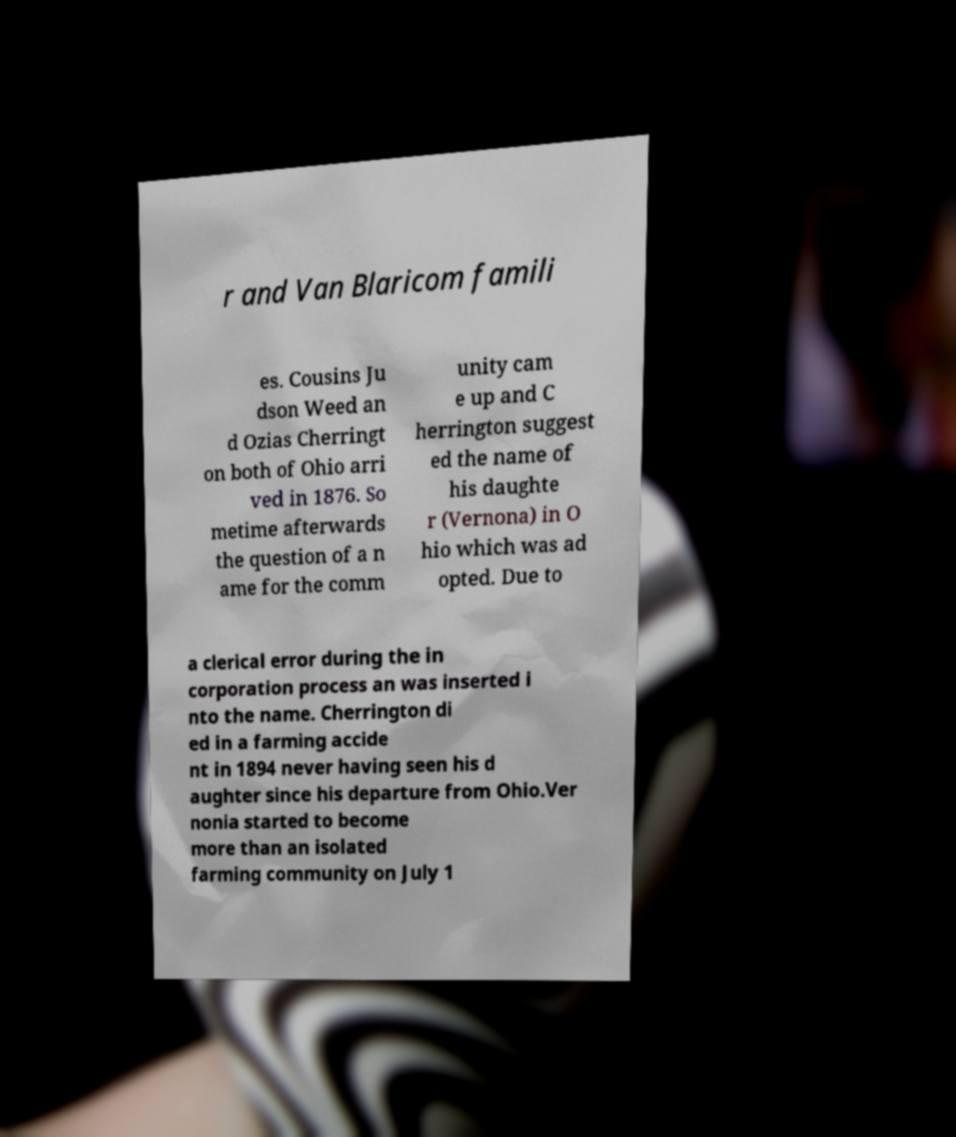I need the written content from this picture converted into text. Can you do that? r and Van Blaricom famili es. Cousins Ju dson Weed an d Ozias Cherringt on both of Ohio arri ved in 1876. So metime afterwards the question of a n ame for the comm unity cam e up and C herrington suggest ed the name of his daughte r (Vernona) in O hio which was ad opted. Due to a clerical error during the in corporation process an was inserted i nto the name. Cherrington di ed in a farming accide nt in 1894 never having seen his d aughter since his departure from Ohio.Ver nonia started to become more than an isolated farming community on July 1 